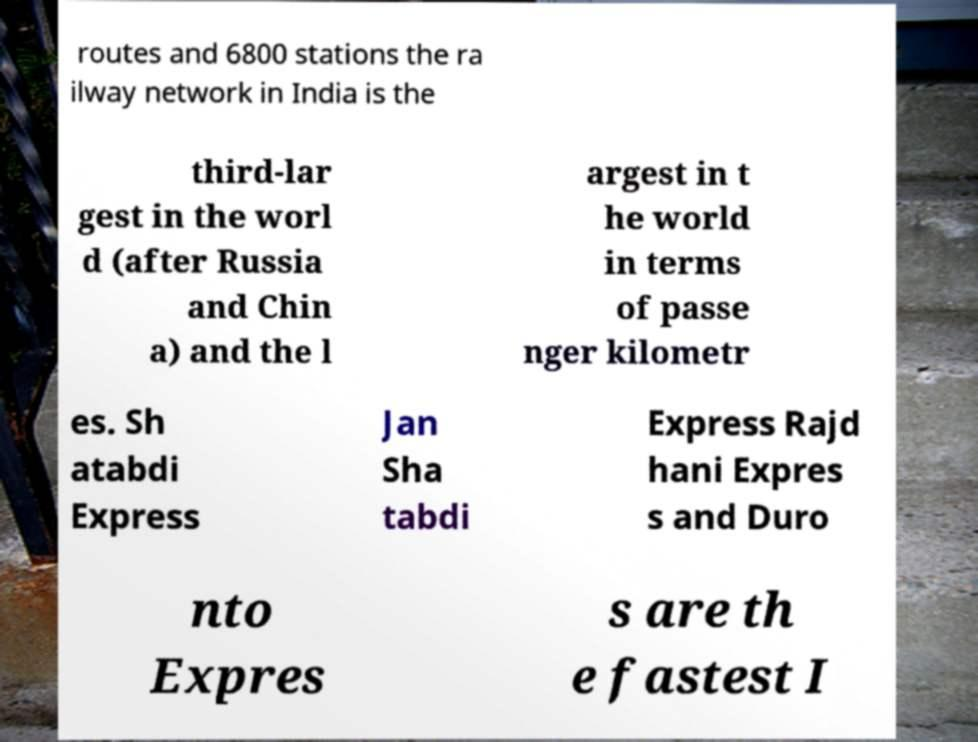There's text embedded in this image that I need extracted. Can you transcribe it verbatim? routes and 6800 stations the ra ilway network in India is the third-lar gest in the worl d (after Russia and Chin a) and the l argest in t he world in terms of passe nger kilometr es. Sh atabdi Express Jan Sha tabdi Express Rajd hani Expres s and Duro nto Expres s are th e fastest I 